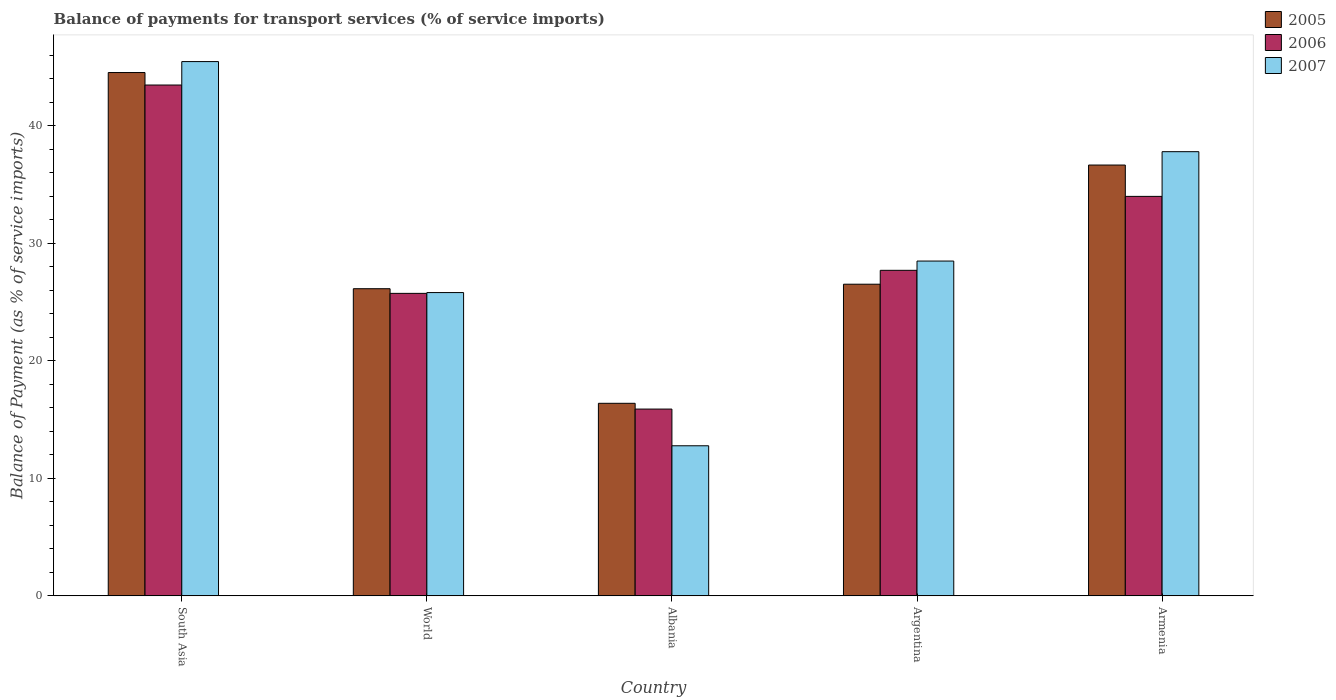How many groups of bars are there?
Provide a short and direct response. 5. Are the number of bars on each tick of the X-axis equal?
Offer a very short reply. Yes. What is the label of the 2nd group of bars from the left?
Provide a short and direct response. World. What is the balance of payments for transport services in 2006 in World?
Make the answer very short. 25.74. Across all countries, what is the maximum balance of payments for transport services in 2006?
Give a very brief answer. 43.48. Across all countries, what is the minimum balance of payments for transport services in 2007?
Give a very brief answer. 12.77. In which country was the balance of payments for transport services in 2007 maximum?
Your answer should be very brief. South Asia. In which country was the balance of payments for transport services in 2006 minimum?
Keep it short and to the point. Albania. What is the total balance of payments for transport services in 2005 in the graph?
Keep it short and to the point. 150.26. What is the difference between the balance of payments for transport services in 2006 in Argentina and that in South Asia?
Offer a terse response. -15.77. What is the difference between the balance of payments for transport services in 2006 in Armenia and the balance of payments for transport services in 2005 in World?
Provide a succinct answer. 7.86. What is the average balance of payments for transport services in 2006 per country?
Give a very brief answer. 29.36. What is the difference between the balance of payments for transport services of/in 2007 and balance of payments for transport services of/in 2006 in Argentina?
Your answer should be compact. 0.79. In how many countries, is the balance of payments for transport services in 2007 greater than 24 %?
Ensure brevity in your answer.  4. What is the ratio of the balance of payments for transport services in 2005 in Albania to that in Argentina?
Your response must be concise. 0.62. Is the balance of payments for transport services in 2005 in South Asia less than that in World?
Your answer should be compact. No. What is the difference between the highest and the second highest balance of payments for transport services in 2006?
Your answer should be compact. -6.29. What is the difference between the highest and the lowest balance of payments for transport services in 2005?
Your response must be concise. 28.15. In how many countries, is the balance of payments for transport services in 2006 greater than the average balance of payments for transport services in 2006 taken over all countries?
Offer a terse response. 2. Is the sum of the balance of payments for transport services in 2007 in Armenia and South Asia greater than the maximum balance of payments for transport services in 2005 across all countries?
Provide a succinct answer. Yes. What does the 2nd bar from the left in South Asia represents?
Make the answer very short. 2006. What does the 2nd bar from the right in South Asia represents?
Make the answer very short. 2006. Is it the case that in every country, the sum of the balance of payments for transport services in 2006 and balance of payments for transport services in 2007 is greater than the balance of payments for transport services in 2005?
Your response must be concise. Yes. How many bars are there?
Offer a very short reply. 15. How many countries are there in the graph?
Provide a succinct answer. 5. What is the difference between two consecutive major ticks on the Y-axis?
Offer a terse response. 10. Where does the legend appear in the graph?
Provide a succinct answer. Top right. How many legend labels are there?
Provide a short and direct response. 3. What is the title of the graph?
Make the answer very short. Balance of payments for transport services (% of service imports). What is the label or title of the X-axis?
Provide a short and direct response. Country. What is the label or title of the Y-axis?
Give a very brief answer. Balance of Payment (as % of service imports). What is the Balance of Payment (as % of service imports) in 2005 in South Asia?
Your answer should be compact. 44.54. What is the Balance of Payment (as % of service imports) in 2006 in South Asia?
Your response must be concise. 43.48. What is the Balance of Payment (as % of service imports) in 2007 in South Asia?
Make the answer very short. 45.47. What is the Balance of Payment (as % of service imports) of 2005 in World?
Your answer should be compact. 26.14. What is the Balance of Payment (as % of service imports) of 2006 in World?
Ensure brevity in your answer.  25.74. What is the Balance of Payment (as % of service imports) of 2007 in World?
Make the answer very short. 25.81. What is the Balance of Payment (as % of service imports) in 2005 in Albania?
Your answer should be very brief. 16.39. What is the Balance of Payment (as % of service imports) in 2006 in Albania?
Your answer should be very brief. 15.9. What is the Balance of Payment (as % of service imports) of 2007 in Albania?
Offer a very short reply. 12.77. What is the Balance of Payment (as % of service imports) in 2005 in Argentina?
Provide a short and direct response. 26.52. What is the Balance of Payment (as % of service imports) in 2006 in Argentina?
Your answer should be very brief. 27.71. What is the Balance of Payment (as % of service imports) of 2007 in Argentina?
Make the answer very short. 28.49. What is the Balance of Payment (as % of service imports) of 2005 in Armenia?
Your answer should be very brief. 36.67. What is the Balance of Payment (as % of service imports) of 2006 in Armenia?
Offer a terse response. 34. What is the Balance of Payment (as % of service imports) of 2007 in Armenia?
Keep it short and to the point. 37.8. Across all countries, what is the maximum Balance of Payment (as % of service imports) of 2005?
Give a very brief answer. 44.54. Across all countries, what is the maximum Balance of Payment (as % of service imports) in 2006?
Provide a succinct answer. 43.48. Across all countries, what is the maximum Balance of Payment (as % of service imports) in 2007?
Give a very brief answer. 45.47. Across all countries, what is the minimum Balance of Payment (as % of service imports) in 2005?
Make the answer very short. 16.39. Across all countries, what is the minimum Balance of Payment (as % of service imports) in 2006?
Give a very brief answer. 15.9. Across all countries, what is the minimum Balance of Payment (as % of service imports) in 2007?
Offer a very short reply. 12.77. What is the total Balance of Payment (as % of service imports) in 2005 in the graph?
Make the answer very short. 150.26. What is the total Balance of Payment (as % of service imports) in 2006 in the graph?
Offer a terse response. 146.82. What is the total Balance of Payment (as % of service imports) in 2007 in the graph?
Give a very brief answer. 150.35. What is the difference between the Balance of Payment (as % of service imports) of 2005 in South Asia and that in World?
Your response must be concise. 18.4. What is the difference between the Balance of Payment (as % of service imports) of 2006 in South Asia and that in World?
Give a very brief answer. 17.73. What is the difference between the Balance of Payment (as % of service imports) in 2007 in South Asia and that in World?
Make the answer very short. 19.66. What is the difference between the Balance of Payment (as % of service imports) of 2005 in South Asia and that in Albania?
Give a very brief answer. 28.15. What is the difference between the Balance of Payment (as % of service imports) of 2006 in South Asia and that in Albania?
Offer a terse response. 27.58. What is the difference between the Balance of Payment (as % of service imports) of 2007 in South Asia and that in Albania?
Offer a terse response. 32.7. What is the difference between the Balance of Payment (as % of service imports) in 2005 in South Asia and that in Argentina?
Offer a terse response. 18.02. What is the difference between the Balance of Payment (as % of service imports) in 2006 in South Asia and that in Argentina?
Your answer should be compact. 15.77. What is the difference between the Balance of Payment (as % of service imports) of 2007 in South Asia and that in Argentina?
Provide a short and direct response. 16.98. What is the difference between the Balance of Payment (as % of service imports) of 2005 in South Asia and that in Armenia?
Your response must be concise. 7.87. What is the difference between the Balance of Payment (as % of service imports) in 2006 in South Asia and that in Armenia?
Your answer should be compact. 9.48. What is the difference between the Balance of Payment (as % of service imports) of 2007 in South Asia and that in Armenia?
Your answer should be compact. 7.67. What is the difference between the Balance of Payment (as % of service imports) of 2005 in World and that in Albania?
Your answer should be very brief. 9.75. What is the difference between the Balance of Payment (as % of service imports) of 2006 in World and that in Albania?
Offer a very short reply. 9.85. What is the difference between the Balance of Payment (as % of service imports) of 2007 in World and that in Albania?
Offer a terse response. 13.04. What is the difference between the Balance of Payment (as % of service imports) in 2005 in World and that in Argentina?
Provide a succinct answer. -0.38. What is the difference between the Balance of Payment (as % of service imports) in 2006 in World and that in Argentina?
Provide a succinct answer. -1.96. What is the difference between the Balance of Payment (as % of service imports) in 2007 in World and that in Argentina?
Your answer should be very brief. -2.68. What is the difference between the Balance of Payment (as % of service imports) in 2005 in World and that in Armenia?
Provide a succinct answer. -10.53. What is the difference between the Balance of Payment (as % of service imports) in 2006 in World and that in Armenia?
Provide a succinct answer. -8.25. What is the difference between the Balance of Payment (as % of service imports) of 2007 in World and that in Armenia?
Provide a short and direct response. -11.99. What is the difference between the Balance of Payment (as % of service imports) of 2005 in Albania and that in Argentina?
Offer a terse response. -10.14. What is the difference between the Balance of Payment (as % of service imports) of 2006 in Albania and that in Argentina?
Provide a succinct answer. -11.81. What is the difference between the Balance of Payment (as % of service imports) in 2007 in Albania and that in Argentina?
Ensure brevity in your answer.  -15.72. What is the difference between the Balance of Payment (as % of service imports) in 2005 in Albania and that in Armenia?
Offer a very short reply. -20.28. What is the difference between the Balance of Payment (as % of service imports) of 2006 in Albania and that in Armenia?
Make the answer very short. -18.1. What is the difference between the Balance of Payment (as % of service imports) in 2007 in Albania and that in Armenia?
Keep it short and to the point. -25.03. What is the difference between the Balance of Payment (as % of service imports) in 2005 in Argentina and that in Armenia?
Ensure brevity in your answer.  -10.14. What is the difference between the Balance of Payment (as % of service imports) in 2006 in Argentina and that in Armenia?
Provide a succinct answer. -6.29. What is the difference between the Balance of Payment (as % of service imports) of 2007 in Argentina and that in Armenia?
Offer a terse response. -9.31. What is the difference between the Balance of Payment (as % of service imports) in 2005 in South Asia and the Balance of Payment (as % of service imports) in 2006 in World?
Offer a very short reply. 18.8. What is the difference between the Balance of Payment (as % of service imports) of 2005 in South Asia and the Balance of Payment (as % of service imports) of 2007 in World?
Provide a short and direct response. 18.73. What is the difference between the Balance of Payment (as % of service imports) of 2006 in South Asia and the Balance of Payment (as % of service imports) of 2007 in World?
Keep it short and to the point. 17.66. What is the difference between the Balance of Payment (as % of service imports) of 2005 in South Asia and the Balance of Payment (as % of service imports) of 2006 in Albania?
Offer a terse response. 28.64. What is the difference between the Balance of Payment (as % of service imports) of 2005 in South Asia and the Balance of Payment (as % of service imports) of 2007 in Albania?
Give a very brief answer. 31.77. What is the difference between the Balance of Payment (as % of service imports) of 2006 in South Asia and the Balance of Payment (as % of service imports) of 2007 in Albania?
Offer a terse response. 30.7. What is the difference between the Balance of Payment (as % of service imports) of 2005 in South Asia and the Balance of Payment (as % of service imports) of 2006 in Argentina?
Provide a short and direct response. 16.83. What is the difference between the Balance of Payment (as % of service imports) of 2005 in South Asia and the Balance of Payment (as % of service imports) of 2007 in Argentina?
Your answer should be compact. 16.04. What is the difference between the Balance of Payment (as % of service imports) in 2006 in South Asia and the Balance of Payment (as % of service imports) in 2007 in Argentina?
Give a very brief answer. 14.98. What is the difference between the Balance of Payment (as % of service imports) of 2005 in South Asia and the Balance of Payment (as % of service imports) of 2006 in Armenia?
Give a very brief answer. 10.54. What is the difference between the Balance of Payment (as % of service imports) in 2005 in South Asia and the Balance of Payment (as % of service imports) in 2007 in Armenia?
Your answer should be compact. 6.74. What is the difference between the Balance of Payment (as % of service imports) in 2006 in South Asia and the Balance of Payment (as % of service imports) in 2007 in Armenia?
Keep it short and to the point. 5.67. What is the difference between the Balance of Payment (as % of service imports) of 2005 in World and the Balance of Payment (as % of service imports) of 2006 in Albania?
Provide a short and direct response. 10.24. What is the difference between the Balance of Payment (as % of service imports) of 2005 in World and the Balance of Payment (as % of service imports) of 2007 in Albania?
Provide a succinct answer. 13.37. What is the difference between the Balance of Payment (as % of service imports) in 2006 in World and the Balance of Payment (as % of service imports) in 2007 in Albania?
Ensure brevity in your answer.  12.97. What is the difference between the Balance of Payment (as % of service imports) of 2005 in World and the Balance of Payment (as % of service imports) of 2006 in Argentina?
Your answer should be very brief. -1.57. What is the difference between the Balance of Payment (as % of service imports) in 2005 in World and the Balance of Payment (as % of service imports) in 2007 in Argentina?
Offer a terse response. -2.35. What is the difference between the Balance of Payment (as % of service imports) of 2006 in World and the Balance of Payment (as % of service imports) of 2007 in Argentina?
Provide a succinct answer. -2.75. What is the difference between the Balance of Payment (as % of service imports) in 2005 in World and the Balance of Payment (as % of service imports) in 2006 in Armenia?
Your response must be concise. -7.86. What is the difference between the Balance of Payment (as % of service imports) in 2005 in World and the Balance of Payment (as % of service imports) in 2007 in Armenia?
Offer a terse response. -11.66. What is the difference between the Balance of Payment (as % of service imports) of 2006 in World and the Balance of Payment (as % of service imports) of 2007 in Armenia?
Your answer should be very brief. -12.06. What is the difference between the Balance of Payment (as % of service imports) of 2005 in Albania and the Balance of Payment (as % of service imports) of 2006 in Argentina?
Make the answer very short. -11.32. What is the difference between the Balance of Payment (as % of service imports) of 2005 in Albania and the Balance of Payment (as % of service imports) of 2007 in Argentina?
Make the answer very short. -12.11. What is the difference between the Balance of Payment (as % of service imports) of 2006 in Albania and the Balance of Payment (as % of service imports) of 2007 in Argentina?
Provide a succinct answer. -12.6. What is the difference between the Balance of Payment (as % of service imports) in 2005 in Albania and the Balance of Payment (as % of service imports) in 2006 in Armenia?
Provide a succinct answer. -17.61. What is the difference between the Balance of Payment (as % of service imports) of 2005 in Albania and the Balance of Payment (as % of service imports) of 2007 in Armenia?
Give a very brief answer. -21.42. What is the difference between the Balance of Payment (as % of service imports) of 2006 in Albania and the Balance of Payment (as % of service imports) of 2007 in Armenia?
Your answer should be very brief. -21.91. What is the difference between the Balance of Payment (as % of service imports) in 2005 in Argentina and the Balance of Payment (as % of service imports) in 2006 in Armenia?
Provide a short and direct response. -7.47. What is the difference between the Balance of Payment (as % of service imports) of 2005 in Argentina and the Balance of Payment (as % of service imports) of 2007 in Armenia?
Keep it short and to the point. -11.28. What is the difference between the Balance of Payment (as % of service imports) in 2006 in Argentina and the Balance of Payment (as % of service imports) in 2007 in Armenia?
Offer a terse response. -10.1. What is the average Balance of Payment (as % of service imports) of 2005 per country?
Your answer should be compact. 30.05. What is the average Balance of Payment (as % of service imports) of 2006 per country?
Ensure brevity in your answer.  29.36. What is the average Balance of Payment (as % of service imports) in 2007 per country?
Give a very brief answer. 30.07. What is the difference between the Balance of Payment (as % of service imports) in 2005 and Balance of Payment (as % of service imports) in 2006 in South Asia?
Offer a terse response. 1.06. What is the difference between the Balance of Payment (as % of service imports) in 2005 and Balance of Payment (as % of service imports) in 2007 in South Asia?
Provide a short and direct response. -0.93. What is the difference between the Balance of Payment (as % of service imports) of 2006 and Balance of Payment (as % of service imports) of 2007 in South Asia?
Provide a short and direct response. -2. What is the difference between the Balance of Payment (as % of service imports) of 2005 and Balance of Payment (as % of service imports) of 2006 in World?
Your answer should be compact. 0.4. What is the difference between the Balance of Payment (as % of service imports) in 2005 and Balance of Payment (as % of service imports) in 2007 in World?
Your answer should be compact. 0.33. What is the difference between the Balance of Payment (as % of service imports) in 2006 and Balance of Payment (as % of service imports) in 2007 in World?
Offer a terse response. -0.07. What is the difference between the Balance of Payment (as % of service imports) in 2005 and Balance of Payment (as % of service imports) in 2006 in Albania?
Offer a terse response. 0.49. What is the difference between the Balance of Payment (as % of service imports) of 2005 and Balance of Payment (as % of service imports) of 2007 in Albania?
Give a very brief answer. 3.61. What is the difference between the Balance of Payment (as % of service imports) in 2006 and Balance of Payment (as % of service imports) in 2007 in Albania?
Give a very brief answer. 3.12. What is the difference between the Balance of Payment (as % of service imports) of 2005 and Balance of Payment (as % of service imports) of 2006 in Argentina?
Provide a short and direct response. -1.18. What is the difference between the Balance of Payment (as % of service imports) in 2005 and Balance of Payment (as % of service imports) in 2007 in Argentina?
Keep it short and to the point. -1.97. What is the difference between the Balance of Payment (as % of service imports) in 2006 and Balance of Payment (as % of service imports) in 2007 in Argentina?
Provide a short and direct response. -0.79. What is the difference between the Balance of Payment (as % of service imports) of 2005 and Balance of Payment (as % of service imports) of 2006 in Armenia?
Give a very brief answer. 2.67. What is the difference between the Balance of Payment (as % of service imports) of 2005 and Balance of Payment (as % of service imports) of 2007 in Armenia?
Your response must be concise. -1.14. What is the difference between the Balance of Payment (as % of service imports) of 2006 and Balance of Payment (as % of service imports) of 2007 in Armenia?
Provide a succinct answer. -3.8. What is the ratio of the Balance of Payment (as % of service imports) of 2005 in South Asia to that in World?
Give a very brief answer. 1.7. What is the ratio of the Balance of Payment (as % of service imports) of 2006 in South Asia to that in World?
Give a very brief answer. 1.69. What is the ratio of the Balance of Payment (as % of service imports) of 2007 in South Asia to that in World?
Provide a succinct answer. 1.76. What is the ratio of the Balance of Payment (as % of service imports) in 2005 in South Asia to that in Albania?
Offer a very short reply. 2.72. What is the ratio of the Balance of Payment (as % of service imports) in 2006 in South Asia to that in Albania?
Offer a very short reply. 2.73. What is the ratio of the Balance of Payment (as % of service imports) in 2007 in South Asia to that in Albania?
Offer a terse response. 3.56. What is the ratio of the Balance of Payment (as % of service imports) in 2005 in South Asia to that in Argentina?
Keep it short and to the point. 1.68. What is the ratio of the Balance of Payment (as % of service imports) in 2006 in South Asia to that in Argentina?
Offer a very short reply. 1.57. What is the ratio of the Balance of Payment (as % of service imports) in 2007 in South Asia to that in Argentina?
Provide a succinct answer. 1.6. What is the ratio of the Balance of Payment (as % of service imports) in 2005 in South Asia to that in Armenia?
Offer a terse response. 1.21. What is the ratio of the Balance of Payment (as % of service imports) in 2006 in South Asia to that in Armenia?
Make the answer very short. 1.28. What is the ratio of the Balance of Payment (as % of service imports) of 2007 in South Asia to that in Armenia?
Keep it short and to the point. 1.2. What is the ratio of the Balance of Payment (as % of service imports) of 2005 in World to that in Albania?
Your answer should be very brief. 1.6. What is the ratio of the Balance of Payment (as % of service imports) in 2006 in World to that in Albania?
Your answer should be very brief. 1.62. What is the ratio of the Balance of Payment (as % of service imports) of 2007 in World to that in Albania?
Your answer should be compact. 2.02. What is the ratio of the Balance of Payment (as % of service imports) in 2005 in World to that in Argentina?
Offer a terse response. 0.99. What is the ratio of the Balance of Payment (as % of service imports) in 2006 in World to that in Argentina?
Offer a terse response. 0.93. What is the ratio of the Balance of Payment (as % of service imports) in 2007 in World to that in Argentina?
Keep it short and to the point. 0.91. What is the ratio of the Balance of Payment (as % of service imports) in 2005 in World to that in Armenia?
Your response must be concise. 0.71. What is the ratio of the Balance of Payment (as % of service imports) in 2006 in World to that in Armenia?
Your answer should be compact. 0.76. What is the ratio of the Balance of Payment (as % of service imports) in 2007 in World to that in Armenia?
Provide a short and direct response. 0.68. What is the ratio of the Balance of Payment (as % of service imports) in 2005 in Albania to that in Argentina?
Provide a short and direct response. 0.62. What is the ratio of the Balance of Payment (as % of service imports) in 2006 in Albania to that in Argentina?
Offer a terse response. 0.57. What is the ratio of the Balance of Payment (as % of service imports) in 2007 in Albania to that in Argentina?
Offer a terse response. 0.45. What is the ratio of the Balance of Payment (as % of service imports) of 2005 in Albania to that in Armenia?
Make the answer very short. 0.45. What is the ratio of the Balance of Payment (as % of service imports) of 2006 in Albania to that in Armenia?
Keep it short and to the point. 0.47. What is the ratio of the Balance of Payment (as % of service imports) in 2007 in Albania to that in Armenia?
Offer a very short reply. 0.34. What is the ratio of the Balance of Payment (as % of service imports) of 2005 in Argentina to that in Armenia?
Ensure brevity in your answer.  0.72. What is the ratio of the Balance of Payment (as % of service imports) in 2006 in Argentina to that in Armenia?
Give a very brief answer. 0.81. What is the ratio of the Balance of Payment (as % of service imports) of 2007 in Argentina to that in Armenia?
Your answer should be compact. 0.75. What is the difference between the highest and the second highest Balance of Payment (as % of service imports) of 2005?
Give a very brief answer. 7.87. What is the difference between the highest and the second highest Balance of Payment (as % of service imports) of 2006?
Provide a short and direct response. 9.48. What is the difference between the highest and the second highest Balance of Payment (as % of service imports) of 2007?
Offer a terse response. 7.67. What is the difference between the highest and the lowest Balance of Payment (as % of service imports) in 2005?
Offer a terse response. 28.15. What is the difference between the highest and the lowest Balance of Payment (as % of service imports) of 2006?
Provide a short and direct response. 27.58. What is the difference between the highest and the lowest Balance of Payment (as % of service imports) of 2007?
Your answer should be very brief. 32.7. 